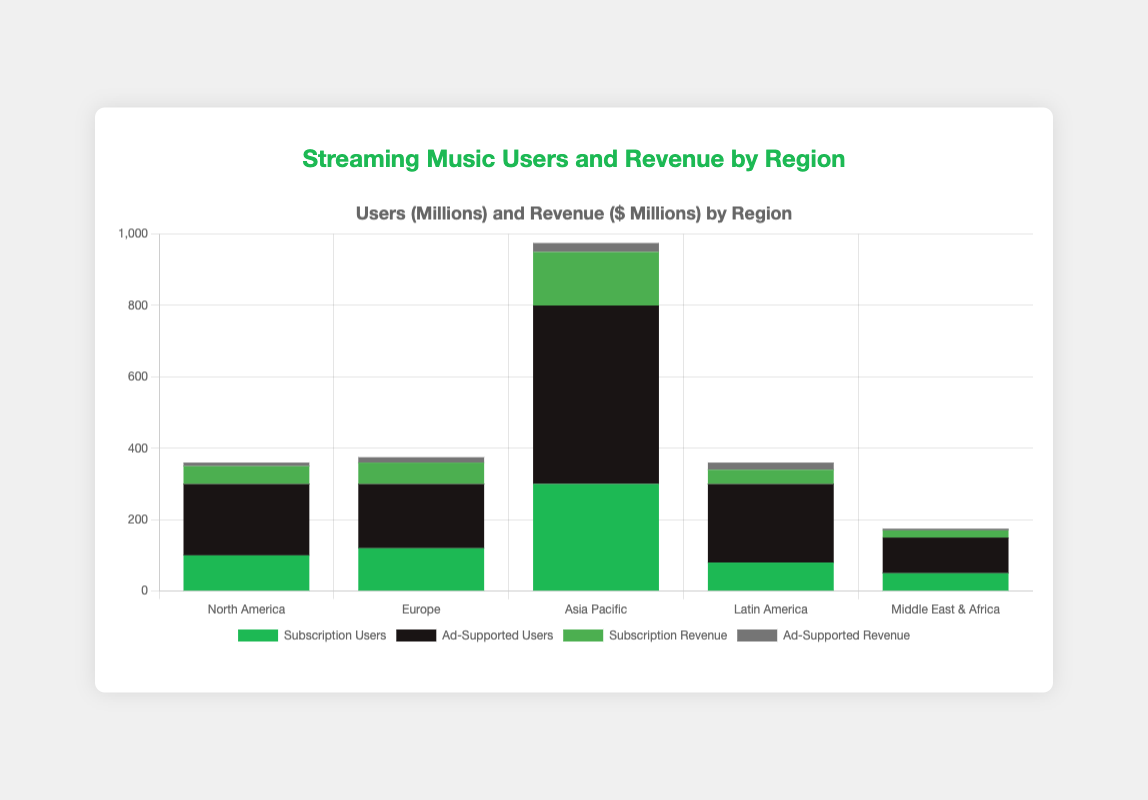What is the total number of subscription users across all regions? Add the number of subscription users from each region: 100 (North America) + 120 (Europe) + 300 (Asia Pacific) + 80 (Latin America) + 50 (Middle East & Africa) = 650
Answer: 650 Which region has the highest ad-supported revenue? Look at the ad-supported revenue bars and find the tallest one representing a region. Asia Pacific has the highest ad-supported revenue with 25 million dollars.
Answer: Asia Pacific Is there any region where subscription revenue is higher than ad-supported revenue? Compare the height of the subscription revenue bars to the ad-supported revenue bars for each region. For all regions, the subscription revenue bar is higher than the ad-supported revenue bar.
Answer: Yes, all regions Compare the total number of ad-supported users to subscription users globally. Sum up the ad-supported users: 200 (North America) + 180 (Europe) + 500 (Asia Pacific) + 220 (Latin America) + 100 (Middle East & Africa) = 1200 and subscription users: 100 (North America) + 120 (Europe) + 300 (Asia Pacific) + 80 (Latin America) + 50 (Middle East & Africa) = 650. Ad-supported users are 1200, which is higher than the subscription users, 650.
Answer: Ad-supported users are higher How much higher are the total subscription revenues compared to ad-supported revenues globally? Sum the subscription revenues: 50 (North America) + 60 (Europe) + 150 (Asia Pacific) + 40 (Latin America) + 20 (Middle East & Africa) = 320 and the ad-supported revenues: 10 (North America) + 15 (Europe) + 25 (Asia Pacific) + 20 (Latin America) + 5 (Middle East & Africa) = 75. The difference is 320 - 75 = 245.
Answer: 245 What is the ratio of subscription revenue to ad-supported revenue in Europe? Divide the subscription revenue by the ad-supported revenue for Europe: 60 / 15 = 4
Answer: 4 